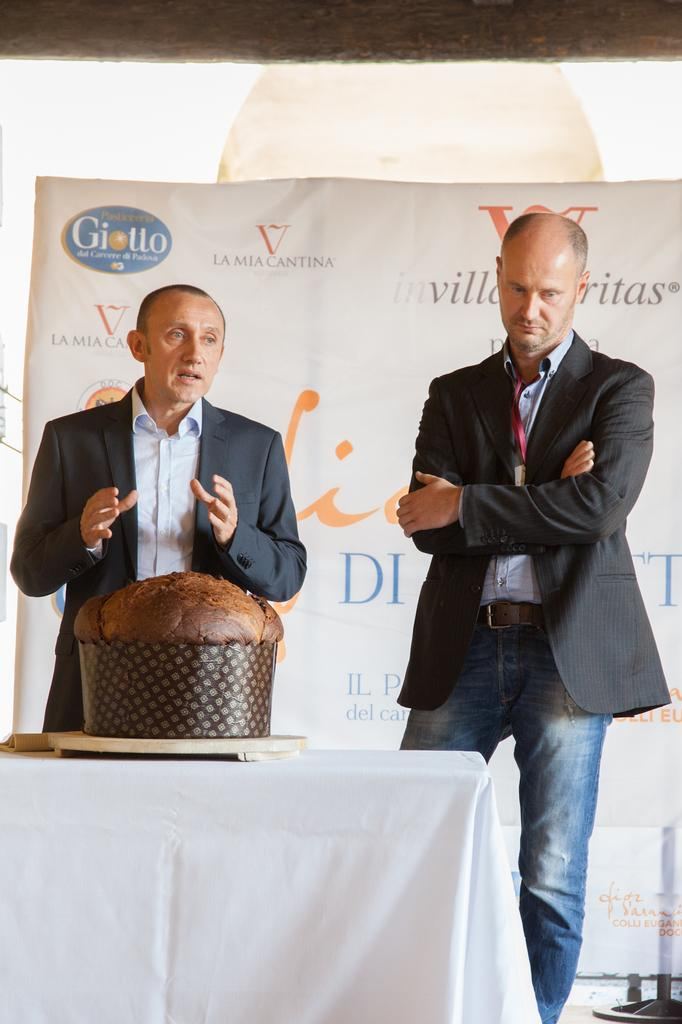How many men are present in the image? There are two men standing in the image. What is one of the men doing in the image? There is a man speaking in the image. What is on the table in the image? There is a cake on a table in the image. What can be seen in the background of the image? There is a hoarding visible in the image. What type of wool is being used to make the cushions in the image? There are no cushions present in the image, so it is not possible to determine the type of wool being used. How many planes are visible in the image? There are no planes visible in the image. 